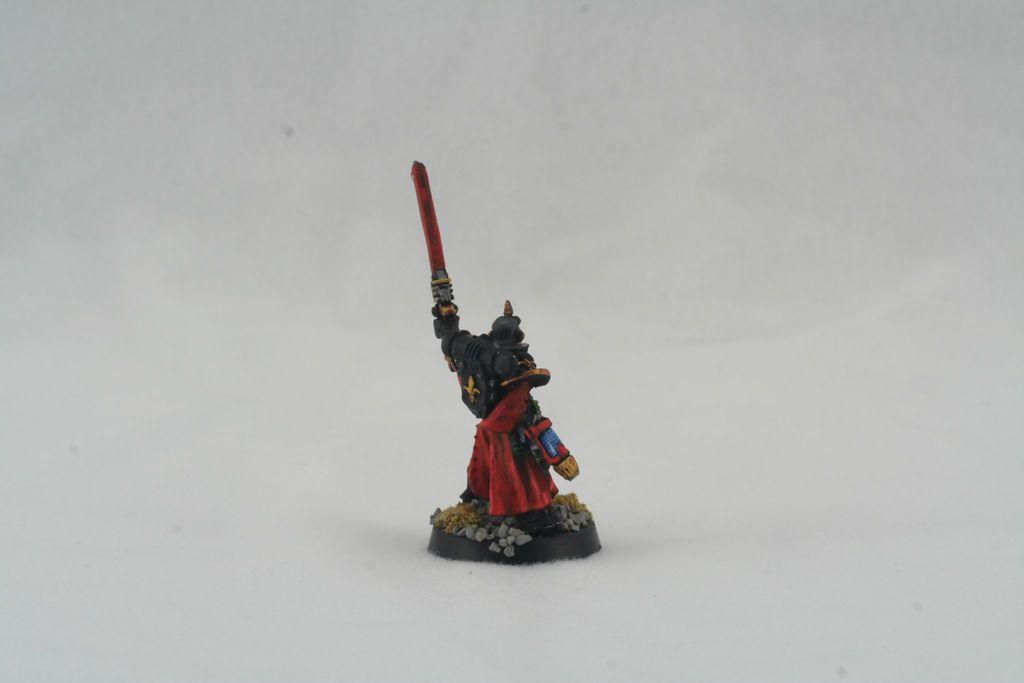What object in the image resembles a person? There is a toy in the image that appears to be a person holding a sword. What is the toy holding in its hand? The toy is holding a sword in its hand. What type of fruit is visible on top of the toy's head in the image? There is no fruit visible on top of the toy's head in the image. 